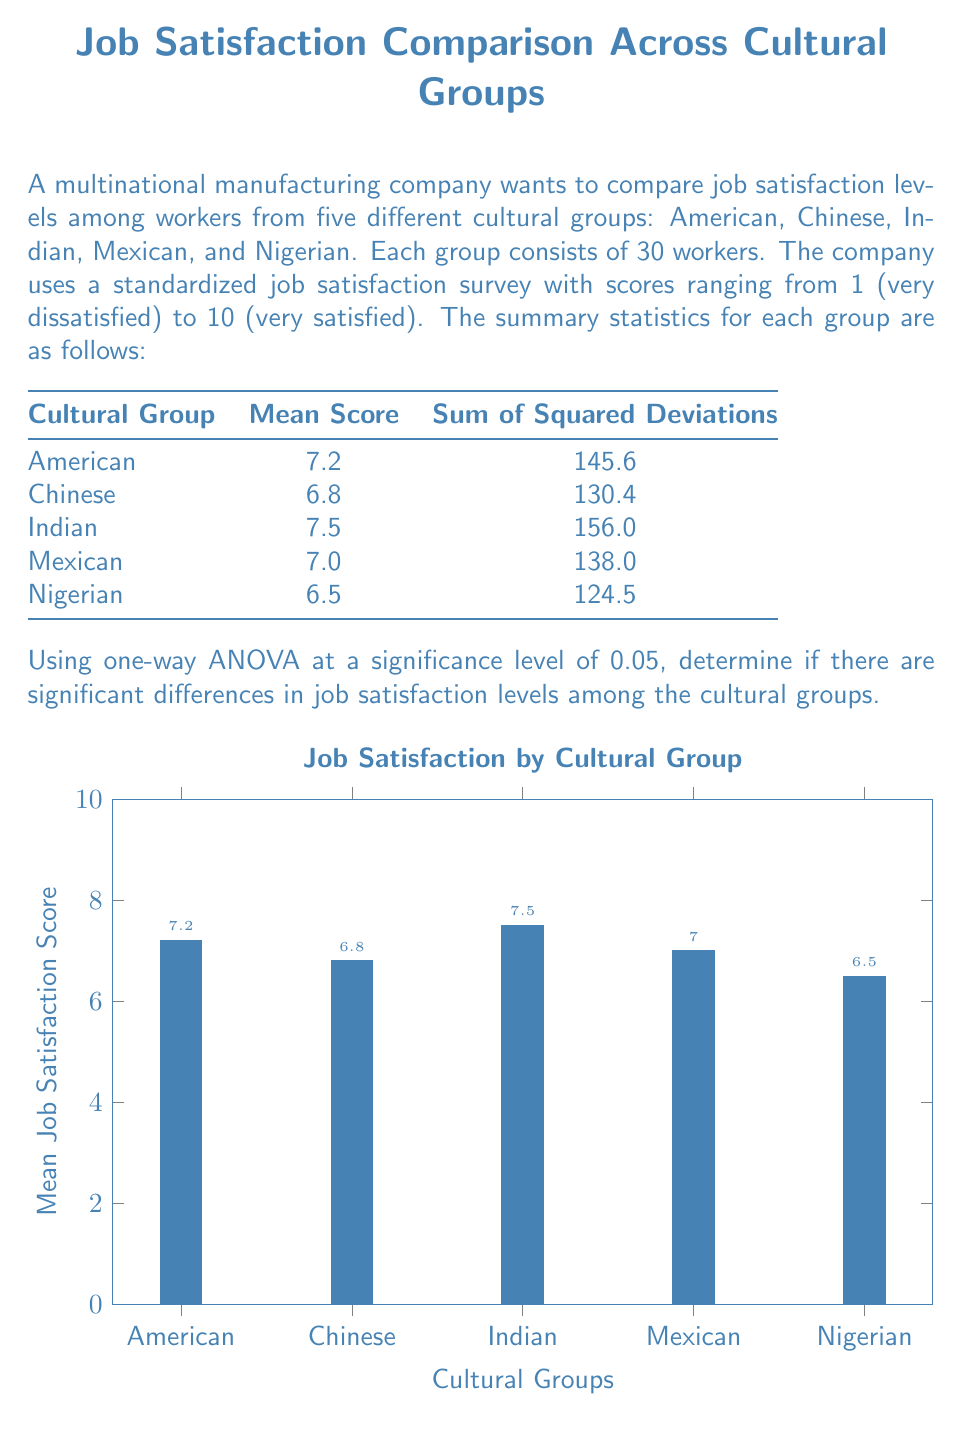Help me with this question. To perform a one-way ANOVA, we'll follow these steps:

1) Calculate the total sum of squares (SST):
   $$SST = \sum_{i=1}^k \sum_{j=1}^{n_i} (X_{ij} - \bar{X})^2$$
   where $k$ is the number of groups and $n_i$ is the sample size of each group.

2) Calculate the between-group sum of squares (SSB):
   $$SSB = \sum_{i=1}^k n_i(\bar{X_i} - \bar{X})^2$$

3) Calculate the within-group sum of squares (SSW):
   $$SSW = SST - SSB$$

4) Calculate degrees of freedom:
   $df_{between} = k - 1 = 5 - 1 = 4$
   $df_{within} = N - k = 150 - 5 = 145$
   $df_{total} = N - 1 = 150 - 1 = 149$

5) Calculate mean squares:
   $$MS_{between} = \frac{SSB}{df_{between}}$$
   $$MS_{within} = \frac{SSW}{df_{within}}$$

6) Calculate F-statistic:
   $$F = \frac{MS_{between}}{MS_{within}}$$

7) Compare F-statistic with critical F-value.

Let's proceed with the calculations:

Grand mean: $\bar{X} = \frac{7.2 + 6.8 + 7.5 + 7.0 + 6.5}{5} = 7$

SSW = 145.6 + 130.4 + 156.0 + 138.0 + 124.5 = 694.5

SSB = 30[(7.2 - 7)^2 + (6.8 - 7)^2 + (7.5 - 7)^2 + (7.0 - 7)^2 + (6.5 - 7)^2]
    = 30(0.04 + 0.04 + 0.25 + 0 + 0.25) = 30(0.58) = 17.4

SST = SSW + SSB = 694.5 + 17.4 = 711.9

$MS_{between} = \frac{SSB}{df_{between}} = \frac{17.4}{4} = 4.35$

$MS_{within} = \frac{SSW}{df_{within}} = \frac{694.5}{145} = 4.79$

$F = \frac{MS_{between}}{MS_{within}} = \frac{4.35}{4.79} = 0.908$

The critical F-value for $\alpha = 0.05$, $df_{between} = 4$, and $df_{within} = 145$ is approximately 2.43.

Since our calculated F-value (0.908) is less than the critical F-value (2.43), we fail to reject the null hypothesis.
Answer: $F(4,145) = 0.908, p > 0.05$. No significant differences in job satisfaction among cultural groups. 